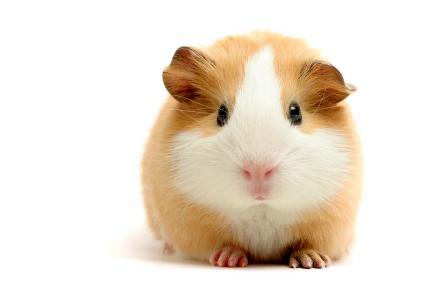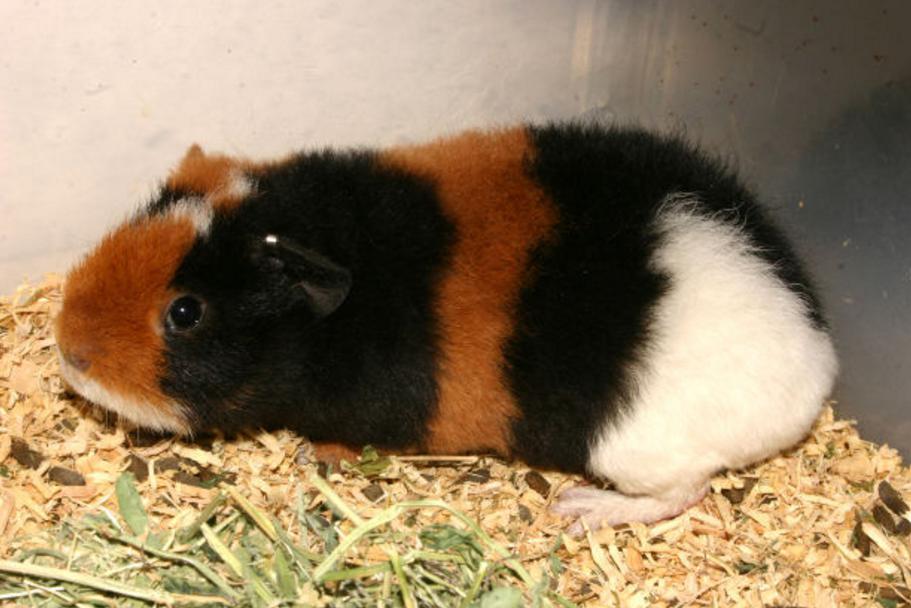The first image is the image on the left, the second image is the image on the right. Examine the images to the left and right. Is the description "One of the guinea pigs has patches of dark brown, black, and white fur." accurate? Answer yes or no. Yes. 